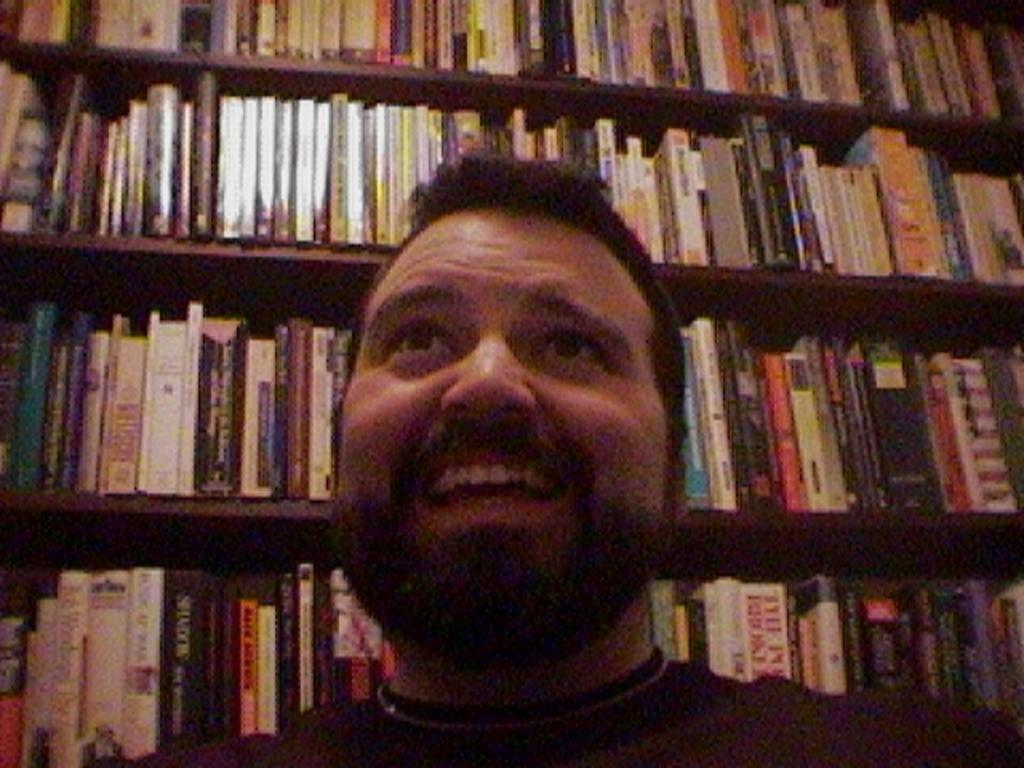Who is present in the image? There is a man in the image. What is the man's facial expression? The man is smiling. What can be seen in the background of the image? There are books in racks in the background of the image. What type of insurance policy is the man discussing in the image? There is no indication in the image that the man is discussing any insurance policies. 